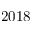Convert formula to latex. <formula><loc_0><loc_0><loc_500><loc_500>2 0 1 8</formula> 